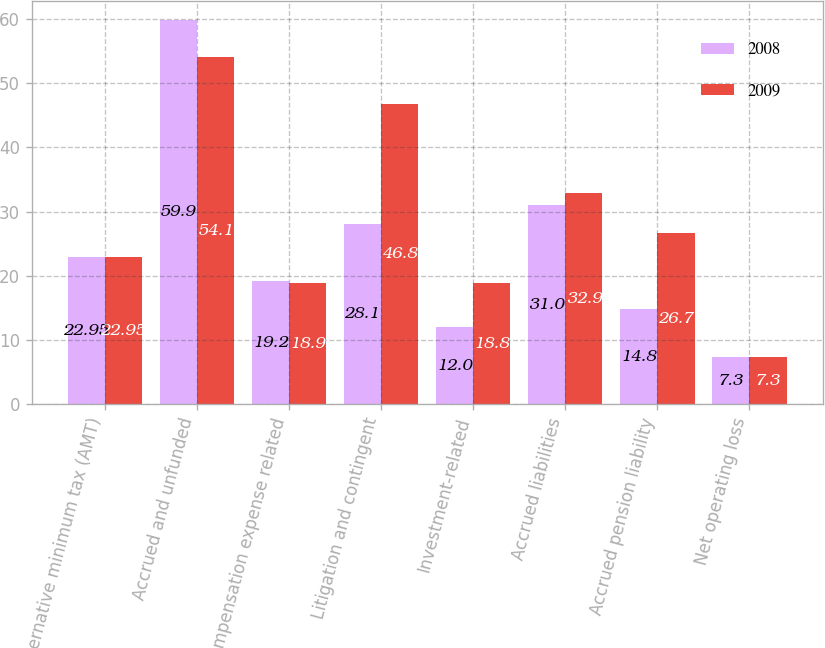Convert chart to OTSL. <chart><loc_0><loc_0><loc_500><loc_500><stacked_bar_chart><ecel><fcel>Alternative minimum tax (AMT)<fcel>Accrued and unfunded<fcel>Compensation expense related<fcel>Litigation and contingent<fcel>Investment-related<fcel>Accrued liabilities<fcel>Accrued pension liability<fcel>Net operating loss<nl><fcel>2008<fcel>22.95<fcel>59.9<fcel>19.2<fcel>28.1<fcel>12<fcel>31<fcel>14.8<fcel>7.3<nl><fcel>2009<fcel>22.95<fcel>54.1<fcel>18.9<fcel>46.8<fcel>18.8<fcel>32.9<fcel>26.7<fcel>7.3<nl></chart> 